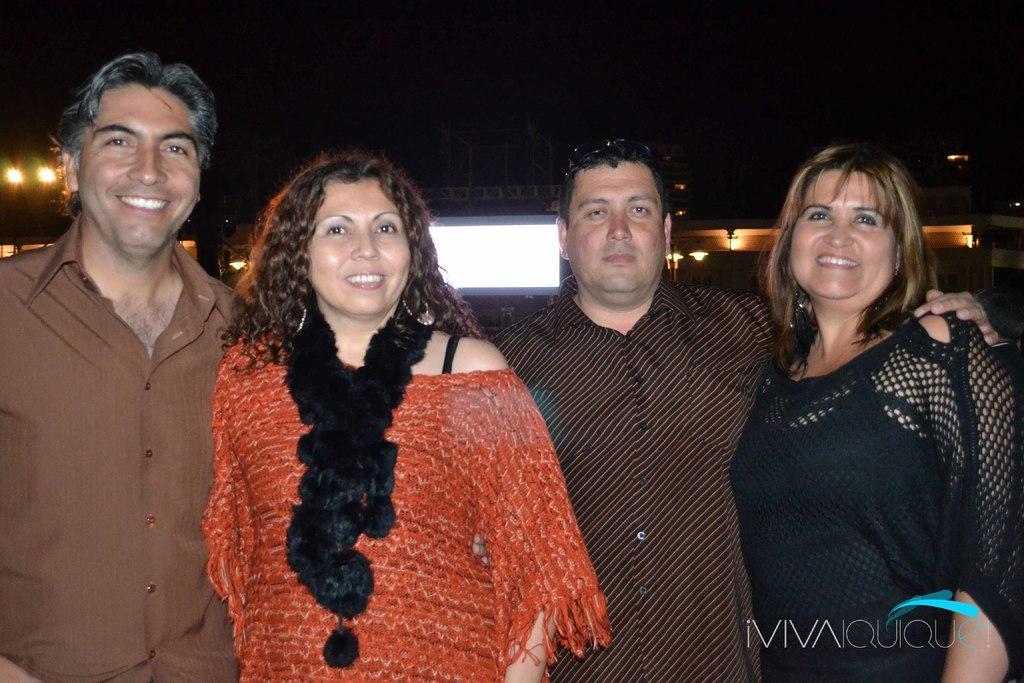Can you describe this image briefly? In this image I can see few persons wearing brown, orange and black colored dresses are standing. In the background I can see few lights, few buildings and the dark sky. 